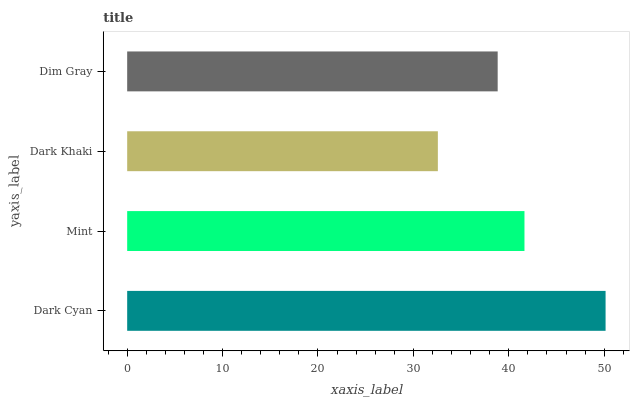Is Dark Khaki the minimum?
Answer yes or no. Yes. Is Dark Cyan the maximum?
Answer yes or no. Yes. Is Mint the minimum?
Answer yes or no. No. Is Mint the maximum?
Answer yes or no. No. Is Dark Cyan greater than Mint?
Answer yes or no. Yes. Is Mint less than Dark Cyan?
Answer yes or no. Yes. Is Mint greater than Dark Cyan?
Answer yes or no. No. Is Dark Cyan less than Mint?
Answer yes or no. No. Is Mint the high median?
Answer yes or no. Yes. Is Dim Gray the low median?
Answer yes or no. Yes. Is Dim Gray the high median?
Answer yes or no. No. Is Mint the low median?
Answer yes or no. No. 